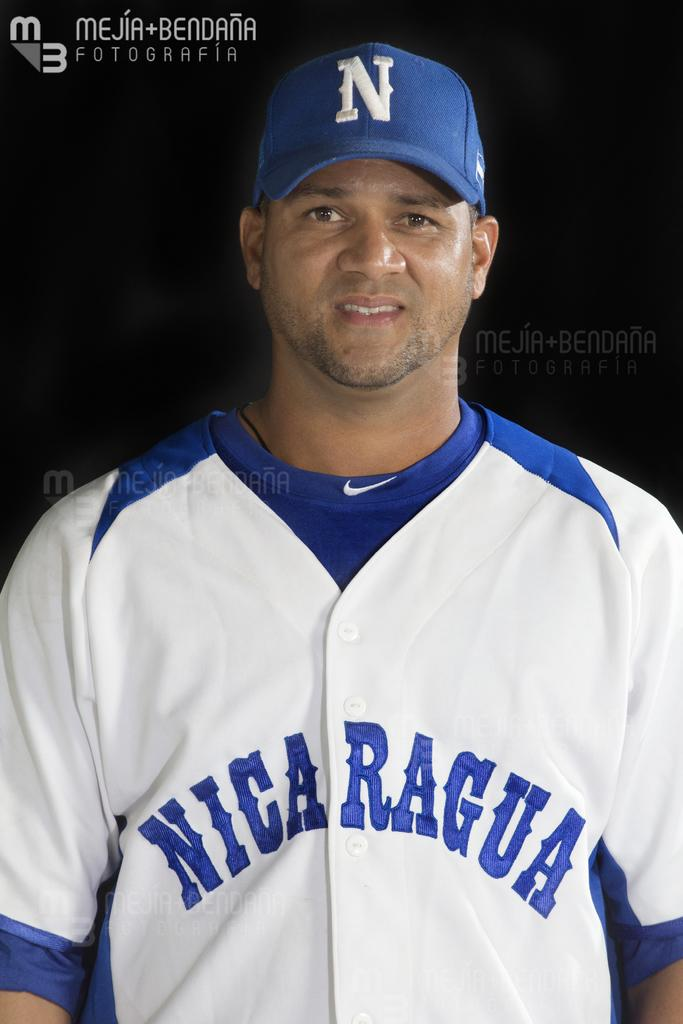<image>
Summarize the visual content of the image. A man in a Nicaragua jersey poses for a photo while wearing his team hat. 